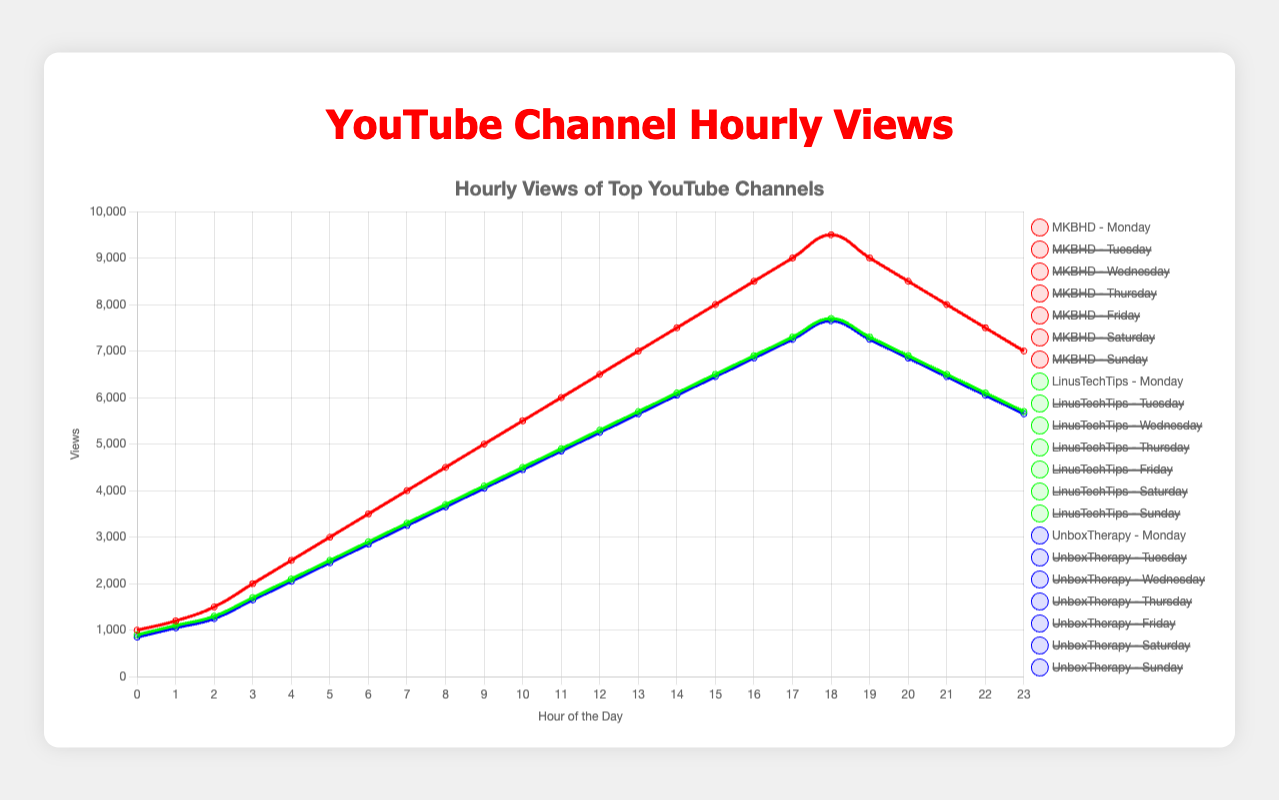What is the peak viewership for MKBHD on Friday? To find the peak viewership, look at the hourly view counts for MKBHD on Friday and identify the highest value. The hour with the highest views for MKBHD on Friday is at 7:00 PM with 9900 views.
Answer: 9900 Compare the peak viewership for MKBHD on Monday and LinusTechTips on Monday. Which is higher and by how much? First, identify the peak viewership for MKBHD on Monday, which is 9500 views at 6:00 PM. Next, identify the peak viewership for LinusTechTips on Monday, which is 7700 views at 5:00 PM. Finally, subtract the peak viewership of LinusTechTips from MKBHD: 9500 - 7700 = 1800.
Answer: MKBHD, 1800 more views What day and time does UnboxTherapy have the most views? Check the highest view count for UnboxTherapy across all days and times. The highest view count is 7850, which occurs on both Thursday and Friday at 6:00 PM.
Answer: Thursday and Friday, 6:00 PM What's the average viewership for LinusTechTips on Sunday between 9:00 AM and 5:00 PM? Calculate the average by summing the viewership from 9:00 AM to 5:00 PM and then dividing by the number of hours. The views for these hours are [4000, 4400, 4800, 5200, 5600, 6000, 6400, 6800, 7200]. Sum: 56000. Average: 56000 / 9 = 6222.22
Answer: 6222.22 During which hour does the viewership for all three channels combined peak on Saturday? Add up the view counts for all three channels at each hour on Saturday and identify the hour with the highest total.
Answer: 6:00 PM What color represents the MKBHD Sunday dataset? Note the color used for the MKBHD Sunday dataset line in the legend. According to the script, MKBHD's data color is red. Hence, the color represents the MKBHD Sunday dataset.
Answer: red Between 1:00 PM and 3:00 PM on Sunday, which channel has the highest average views? Calculate the average views from 1:00 PM to 3:00 PM for each channel: MKBHD: (6100+6600+7100)/3 = 6600, LinusTechTips: (4800+5200+5600)/3 = 5200, UnboxTherapy: (4750+5150+5550)/3 = 5150. MKBHD has the highest average views.
Answer: MKBHD What is the viewership difference between LinusTechTips and UnboxTherapy on Thursday at 2:00 PM? Find and subtract the viewership for each channel at 2:00 PM on Thursday: LinusTechTips (1450), UnboxTherapy (1400). Difference: 1450 - 1400 = 50.
Answer: 50 What is the trend of hourly views for MKBHD on Wednesday? Examine the hourly views for MKBHD on Wednesday. Initially, there is an upward trend from 12:00 AM to 6:00 PM, where views peak at 9200 views at 6:00 PM. After that, there is a downward trend until midnight (7200 views).
Answer: Upward from 12:00 AM to 6:00 PM, then downward 